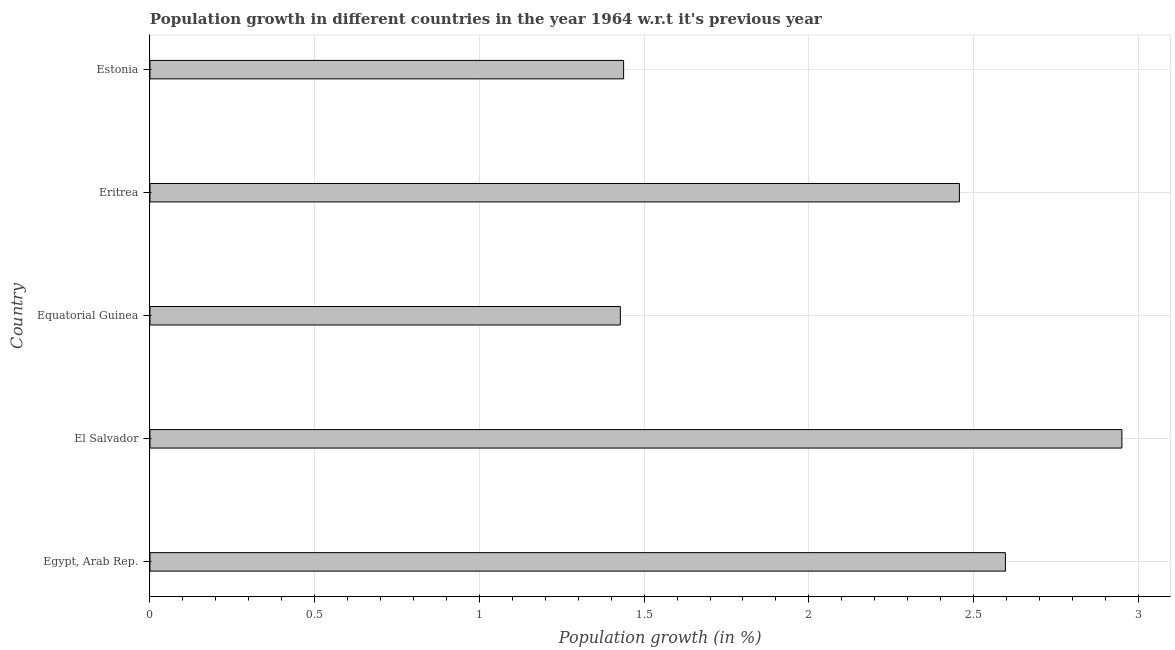Does the graph contain any zero values?
Keep it short and to the point. No. Does the graph contain grids?
Ensure brevity in your answer.  Yes. What is the title of the graph?
Give a very brief answer. Population growth in different countries in the year 1964 w.r.t it's previous year. What is the label or title of the X-axis?
Your response must be concise. Population growth (in %). What is the label or title of the Y-axis?
Provide a succinct answer. Country. What is the population growth in Equatorial Guinea?
Offer a very short reply. 1.43. Across all countries, what is the maximum population growth?
Give a very brief answer. 2.95. Across all countries, what is the minimum population growth?
Offer a very short reply. 1.43. In which country was the population growth maximum?
Ensure brevity in your answer.  El Salvador. In which country was the population growth minimum?
Ensure brevity in your answer.  Equatorial Guinea. What is the sum of the population growth?
Keep it short and to the point. 10.87. What is the difference between the population growth in El Salvador and Estonia?
Offer a terse response. 1.51. What is the average population growth per country?
Your response must be concise. 2.17. What is the median population growth?
Keep it short and to the point. 2.46. What is the ratio of the population growth in Egypt, Arab Rep. to that in El Salvador?
Provide a short and direct response. 0.88. What is the difference between the highest and the second highest population growth?
Your response must be concise. 0.35. Is the sum of the population growth in Equatorial Guinea and Estonia greater than the maximum population growth across all countries?
Your response must be concise. No. What is the difference between the highest and the lowest population growth?
Make the answer very short. 1.52. How many bars are there?
Provide a short and direct response. 5. Are all the bars in the graph horizontal?
Provide a succinct answer. Yes. How many countries are there in the graph?
Your answer should be very brief. 5. What is the Population growth (in %) of Egypt, Arab Rep.?
Give a very brief answer. 2.6. What is the Population growth (in %) of El Salvador?
Your answer should be compact. 2.95. What is the Population growth (in %) in Equatorial Guinea?
Your answer should be very brief. 1.43. What is the Population growth (in %) in Eritrea?
Make the answer very short. 2.46. What is the Population growth (in %) of Estonia?
Provide a succinct answer. 1.44. What is the difference between the Population growth (in %) in Egypt, Arab Rep. and El Salvador?
Provide a short and direct response. -0.35. What is the difference between the Population growth (in %) in Egypt, Arab Rep. and Equatorial Guinea?
Offer a terse response. 1.17. What is the difference between the Population growth (in %) in Egypt, Arab Rep. and Eritrea?
Provide a succinct answer. 0.14. What is the difference between the Population growth (in %) in Egypt, Arab Rep. and Estonia?
Offer a very short reply. 1.16. What is the difference between the Population growth (in %) in El Salvador and Equatorial Guinea?
Give a very brief answer. 1.52. What is the difference between the Population growth (in %) in El Salvador and Eritrea?
Your response must be concise. 0.49. What is the difference between the Population growth (in %) in El Salvador and Estonia?
Your answer should be very brief. 1.51. What is the difference between the Population growth (in %) in Equatorial Guinea and Eritrea?
Offer a terse response. -1.03. What is the difference between the Population growth (in %) in Equatorial Guinea and Estonia?
Offer a terse response. -0.01. What is the difference between the Population growth (in %) in Eritrea and Estonia?
Keep it short and to the point. 1.02. What is the ratio of the Population growth (in %) in Egypt, Arab Rep. to that in Equatorial Guinea?
Provide a short and direct response. 1.82. What is the ratio of the Population growth (in %) in Egypt, Arab Rep. to that in Eritrea?
Offer a terse response. 1.06. What is the ratio of the Population growth (in %) in Egypt, Arab Rep. to that in Estonia?
Provide a short and direct response. 1.81. What is the ratio of the Population growth (in %) in El Salvador to that in Equatorial Guinea?
Make the answer very short. 2.07. What is the ratio of the Population growth (in %) in El Salvador to that in Eritrea?
Your response must be concise. 1.2. What is the ratio of the Population growth (in %) in El Salvador to that in Estonia?
Provide a short and direct response. 2.05. What is the ratio of the Population growth (in %) in Equatorial Guinea to that in Eritrea?
Your answer should be compact. 0.58. What is the ratio of the Population growth (in %) in Equatorial Guinea to that in Estonia?
Provide a succinct answer. 0.99. What is the ratio of the Population growth (in %) in Eritrea to that in Estonia?
Provide a short and direct response. 1.71. 